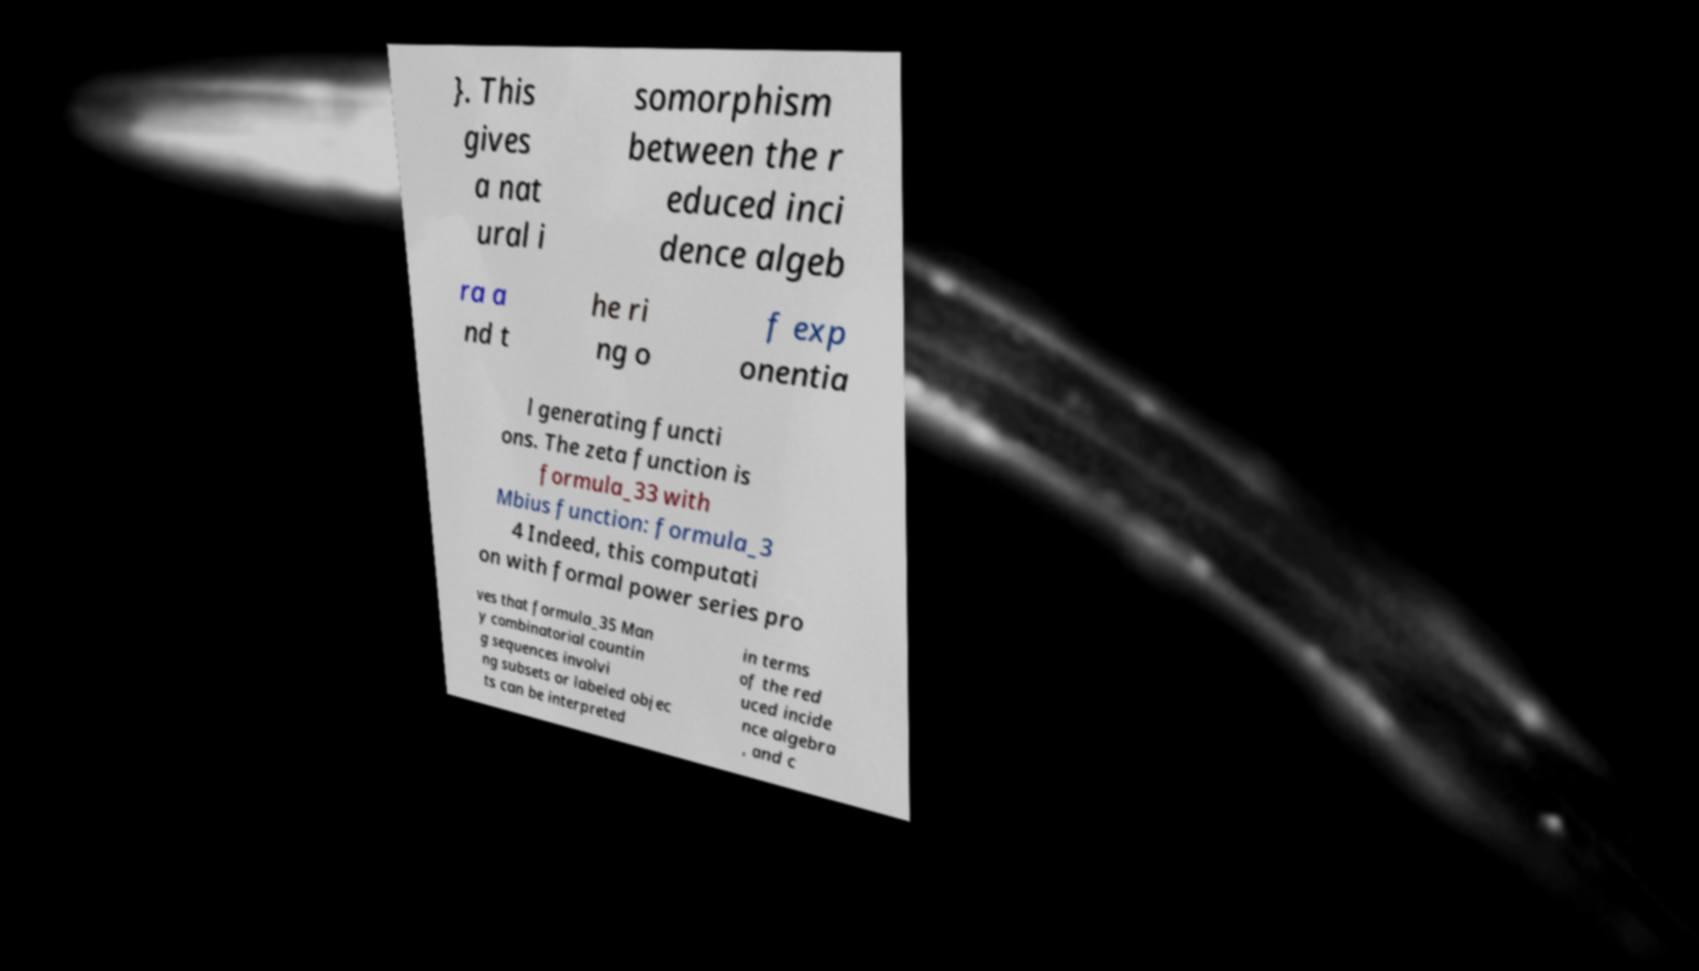There's text embedded in this image that I need extracted. Can you transcribe it verbatim? }. This gives a nat ural i somorphism between the r educed inci dence algeb ra a nd t he ri ng o f exp onentia l generating functi ons. The zeta function is formula_33 with Mbius function: formula_3 4 Indeed, this computati on with formal power series pro ves that formula_35 Man y combinatorial countin g sequences involvi ng subsets or labeled objec ts can be interpreted in terms of the red uced incide nce algebra , and c 